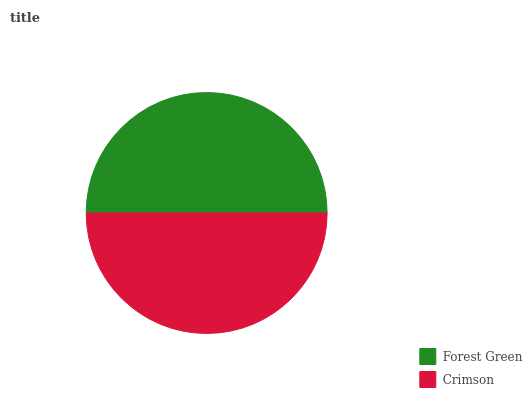Is Crimson the minimum?
Answer yes or no. Yes. Is Forest Green the maximum?
Answer yes or no. Yes. Is Crimson the maximum?
Answer yes or no. No. Is Forest Green greater than Crimson?
Answer yes or no. Yes. Is Crimson less than Forest Green?
Answer yes or no. Yes. Is Crimson greater than Forest Green?
Answer yes or no. No. Is Forest Green less than Crimson?
Answer yes or no. No. Is Forest Green the high median?
Answer yes or no. Yes. Is Crimson the low median?
Answer yes or no. Yes. Is Crimson the high median?
Answer yes or no. No. Is Forest Green the low median?
Answer yes or no. No. 